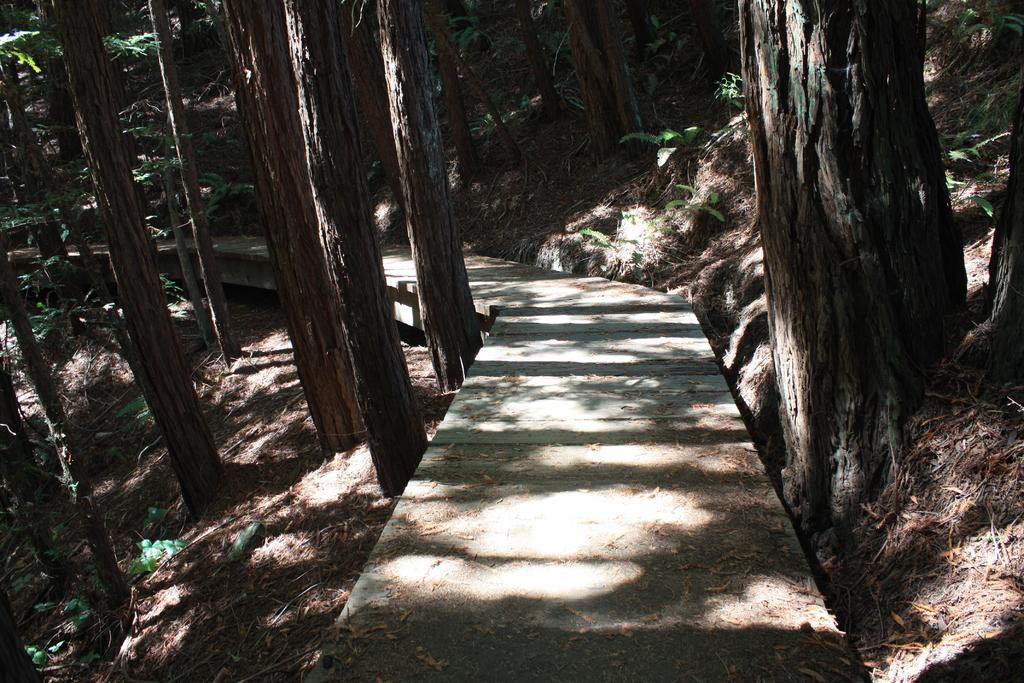What is the main feature in the middle of the image? There is a footpath in the middle of the image. What can be seen on both sides of the footpath? There are trees on both sides of the footpath. What is present on the ground in the image? There are dry leaves on the ground in the image. What type of glass can be seen hanging from the trees in the image? There is no glass present in the image; it features a footpath with trees on both sides and dry leaves on the ground. 